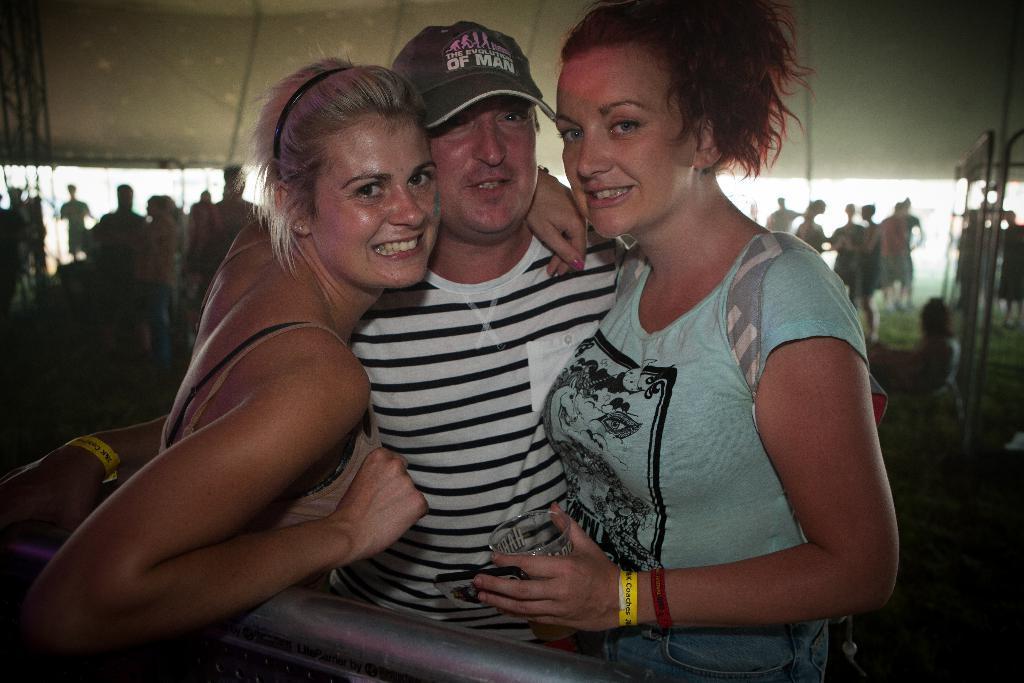Could you give a brief overview of what you see in this image? In this picture we can see a man and two women are standing and smiling in the front, in the background there are some people standing, we can see a blurry background. 